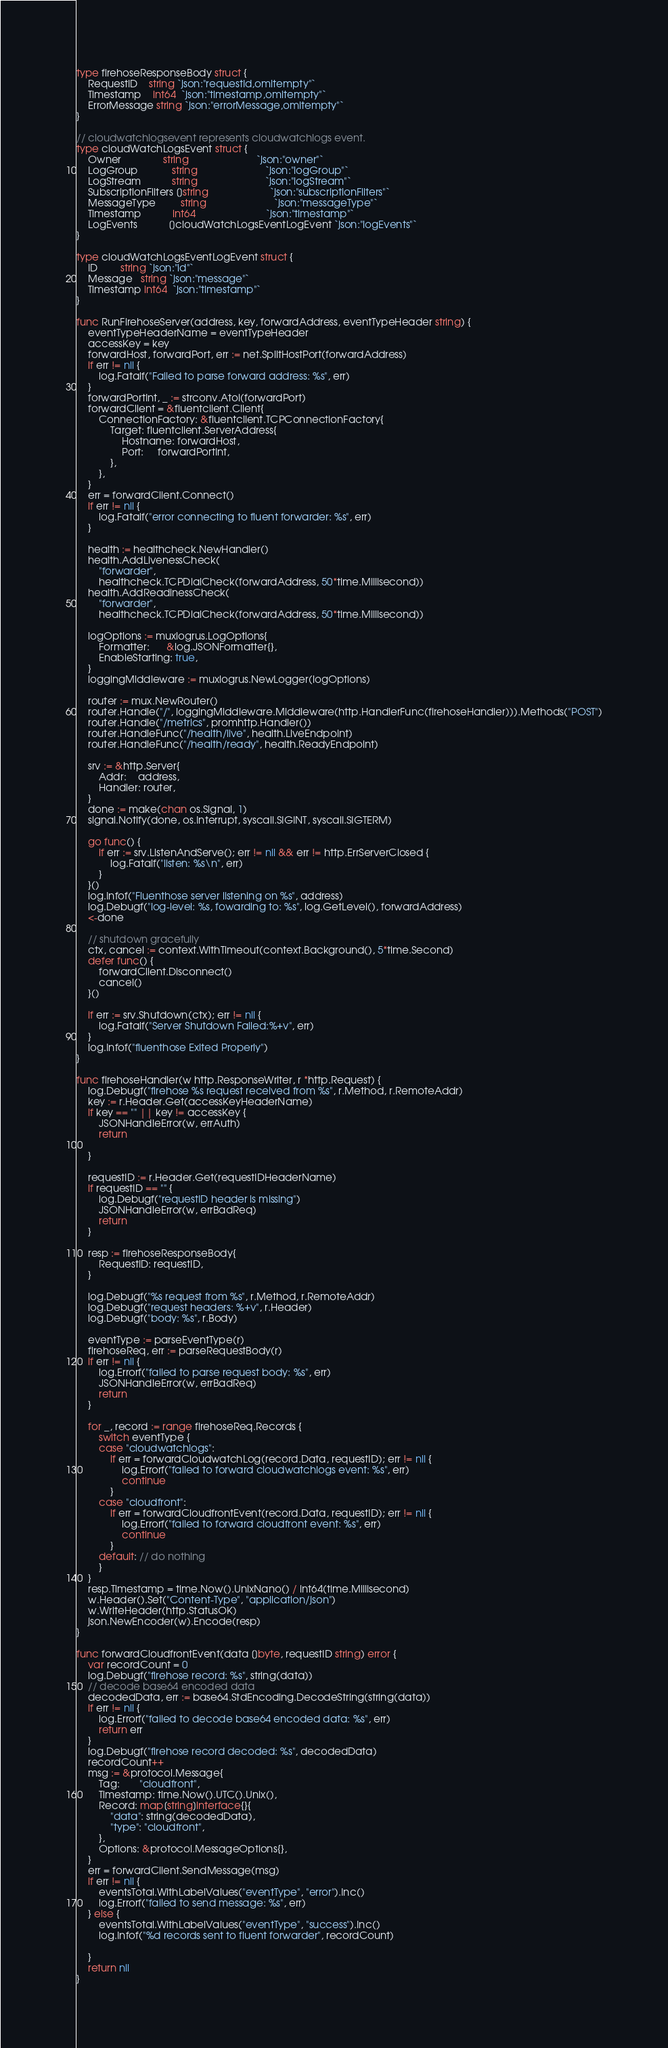<code> <loc_0><loc_0><loc_500><loc_500><_Go_>type firehoseResponseBody struct {
	RequestID    string `json:"requestId,omitempty"`
	Timestamp    int64  `json:"timestamp,omitempty"`
	ErrorMessage string `json:"errorMessage,omitempty"`
}

// cloudwatchlogsevent represents cloudwatchlogs event.
type cloudWatchLogsEvent struct {
	Owner               string                        `json:"owner"`
	LogGroup            string                        `json:"logGroup"`
	LogStream           string                        `json:"logStream"`
	SubscriptionFilters []string                      `json:"subscriptionFilters"`
	MessageType         string                        `json:"messageType"`
	Timestamp           int64                         `json:"timestamp"`
	LogEvents           []cloudWatchLogsEventLogEvent `json:"logEvents"`
}

type cloudWatchLogsEventLogEvent struct {
	ID        string `json:"id"`
	Message   string `json:"message"`
	Timestamp int64  `json:"timestamp"`
}

func RunFirehoseServer(address, key, forwardAddress, eventTypeHeader string) {
	eventTypeHeaderName = eventTypeHeader
	accessKey = key
	forwardHost, forwardPort, err := net.SplitHostPort(forwardAddress)
	if err != nil {
		log.Fatalf("Failed to parse forward address: %s", err)
	}
	forwardPortInt, _ := strconv.Atoi(forwardPort)
	forwardClient = &fluentclient.Client{
		ConnectionFactory: &fluentclient.TCPConnectionFactory{
			Target: fluentclient.ServerAddress{
				Hostname: forwardHost,
				Port:     forwardPortInt,
			},
		},
	}
	err = forwardClient.Connect()
	if err != nil {
		log.Fatalf("error connecting to fluent forwarder: %s", err)
	}

	health := healthcheck.NewHandler()
	health.AddLivenessCheck(
		"forwarder",
		healthcheck.TCPDialCheck(forwardAddress, 50*time.Millisecond))
	health.AddReadinessCheck(
		"forwarder",
		healthcheck.TCPDialCheck(forwardAddress, 50*time.Millisecond))

	logOptions := muxlogrus.LogOptions{
		Formatter:      &log.JSONFormatter{},
		EnableStarting: true,
	}
	loggingMiddleware := muxlogrus.NewLogger(logOptions)

	router := mux.NewRouter()
	router.Handle("/", loggingMiddleware.Middleware(http.HandlerFunc(firehoseHandler))).Methods("POST")
	router.Handle("/metrics", promhttp.Handler())
	router.HandleFunc("/health/live", health.LiveEndpoint)
	router.HandleFunc("/health/ready", health.ReadyEndpoint)

	srv := &http.Server{
		Addr:    address,
		Handler: router,
	}
	done := make(chan os.Signal, 1)
	signal.Notify(done, os.Interrupt, syscall.SIGINT, syscall.SIGTERM)

	go func() {
		if err := srv.ListenAndServe(); err != nil && err != http.ErrServerClosed {
			log.Fatalf("listen: %s\n", err)
		}
	}()
	log.Infof("Fluenthose server listening on %s", address)
	log.Debugf("log-level: %s, fowarding to: %s", log.GetLevel(), forwardAddress)
	<-done

	// shutdown gracefully
	ctx, cancel := context.WithTimeout(context.Background(), 5*time.Second)
	defer func() {
		forwardClient.Disconnect()
		cancel()
	}()

	if err := srv.Shutdown(ctx); err != nil {
		log.Fatalf("Server Shutdown Failed:%+v", err)
	}
	log.Infof("fluenthose Exited Properly")
}

func firehoseHandler(w http.ResponseWriter, r *http.Request) {
	log.Debugf("firehose %s request received from %s", r.Method, r.RemoteAddr)
	key := r.Header.Get(accessKeyHeaderName)
	if key == "" || key != accessKey {
		JSONHandleError(w, errAuth)
		return

	}

	requestID := r.Header.Get(requestIDHeaderName)
	if requestID == "" {
		log.Debugf("requestID header is missing")
		JSONHandleError(w, errBadReq)
		return
	}

	resp := firehoseResponseBody{
		RequestID: requestID,
	}

	log.Debugf("%s request from %s", r.Method, r.RemoteAddr)
	log.Debugf("request headers: %+v", r.Header)
	log.Debugf("body: %s", r.Body)

	eventType := parseEventType(r)
	firehoseReq, err := parseRequestBody(r)
	if err != nil {
		log.Errorf("failed to parse request body: %s", err)
		JSONHandleError(w, errBadReq)
		return
	}

	for _, record := range firehoseReq.Records {
		switch eventType {
		case "cloudwatchlogs":
			if err = forwardCloudwatchLog(record.Data, requestID); err != nil {
				log.Errorf("failed to forward cloudwatchlogs event: %s", err)
				continue
			}
		case "cloudfront":
			if err = forwardCloudfrontEvent(record.Data, requestID); err != nil {
				log.Errorf("failed to forward cloudfront event: %s", err)
				continue
			}
		default: // do nothing
		}
	}
	resp.Timestamp = time.Now().UnixNano() / int64(time.Millisecond)
	w.Header().Set("Content-Type", "application/json")
	w.WriteHeader(http.StatusOK)
	json.NewEncoder(w).Encode(resp)
}

func forwardCloudfrontEvent(data []byte, requestID string) error {
	var recordCount = 0
	log.Debugf("firehose record: %s", string(data))
	// decode base64 encoded data
	decodedData, err := base64.StdEncoding.DecodeString(string(data))
	if err != nil {
		log.Errorf("failed to decode base64 encoded data: %s", err)
		return err
	}
	log.Debugf("firehose record decoded: %s", decodedData)
	recordCount++
	msg := &protocol.Message{
		Tag:       "cloudfront",
		Timestamp: time.Now().UTC().Unix(),
		Record: map[string]interface{}{
			"data": string(decodedData),
			"type": "cloudfront",
		},
		Options: &protocol.MessageOptions{},
	}
	err = forwardClient.SendMessage(msg)
	if err != nil {
		eventsTotal.WithLabelValues("eventType", "error").Inc()
		log.Errorf("failed to send message: %s", err)
	} else {
		eventsTotal.WithLabelValues("eventType", "success").Inc()
		log.Infof("%d records sent to fluent forwarder", recordCount)

	}
	return nil
}
</code> 